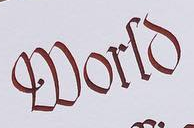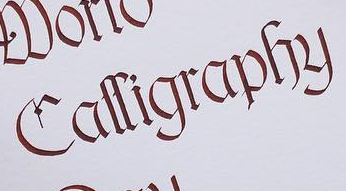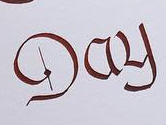Read the text content from these images in order, separated by a semicolon. World; Calligraphy; Day 